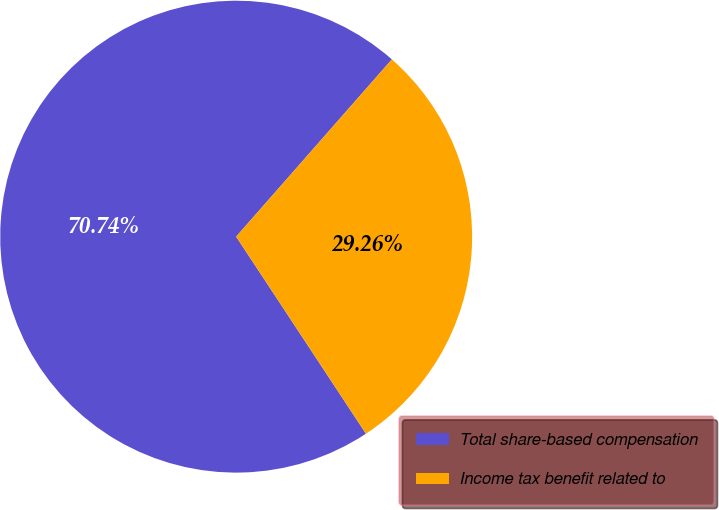<chart> <loc_0><loc_0><loc_500><loc_500><pie_chart><fcel>Total share-based compensation<fcel>Income tax benefit related to<nl><fcel>70.74%<fcel>29.26%<nl></chart> 